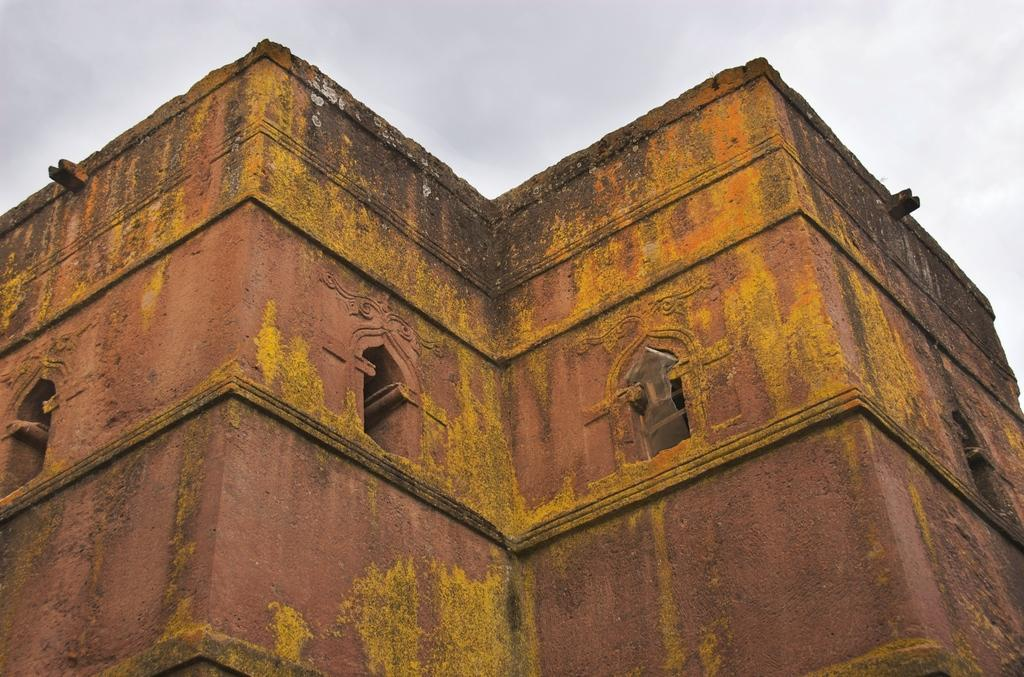Where was the image taken? The image was taken outdoors. What can be seen in the sky in the image? There is a sky with clouds visible in the image. What type of structure is present in the image? There is a fort with walls in the image. What type of stocking is hanging from the fort in the image? There is no stocking hanging from the fort in the image. Can you see the pet of the person who took the image in the picture? There is no pet visible in the image. 